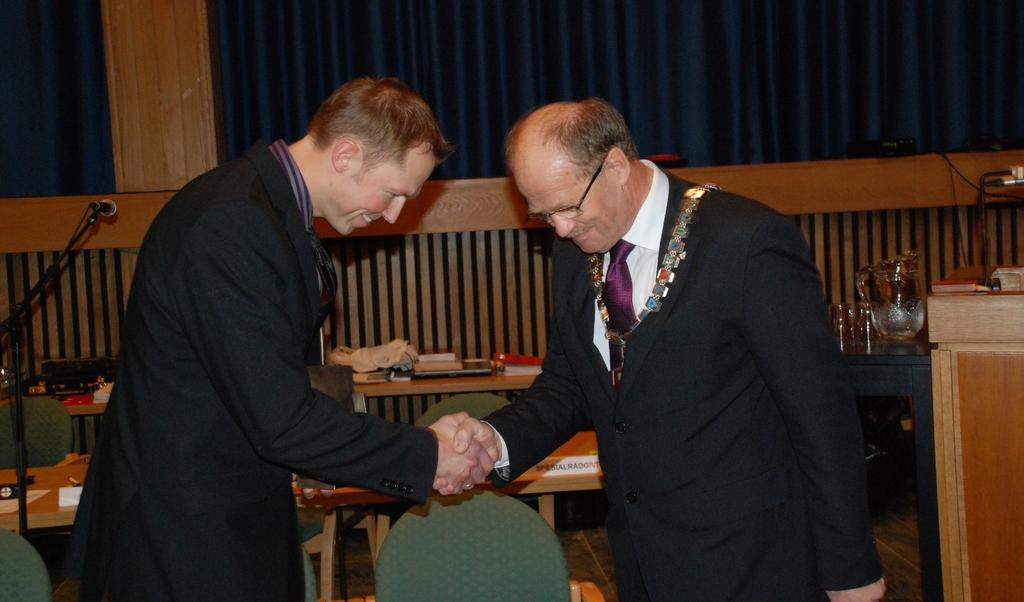How many people are in the image? There are two people in the image. What are the two people doing? The two people are shaking hands and smiling. What can be seen in the background of the image? There is a table in the background of the image. What is placed on the table? Accessories are placed on the table. What is present in the image that might be used for covering or decoration? There is a curtain in the image. What type of toys can be seen on the table in the image? There are no toys present on the table in the image. What is the purpose of the zinc in the image? There is no zinc present in the image. 